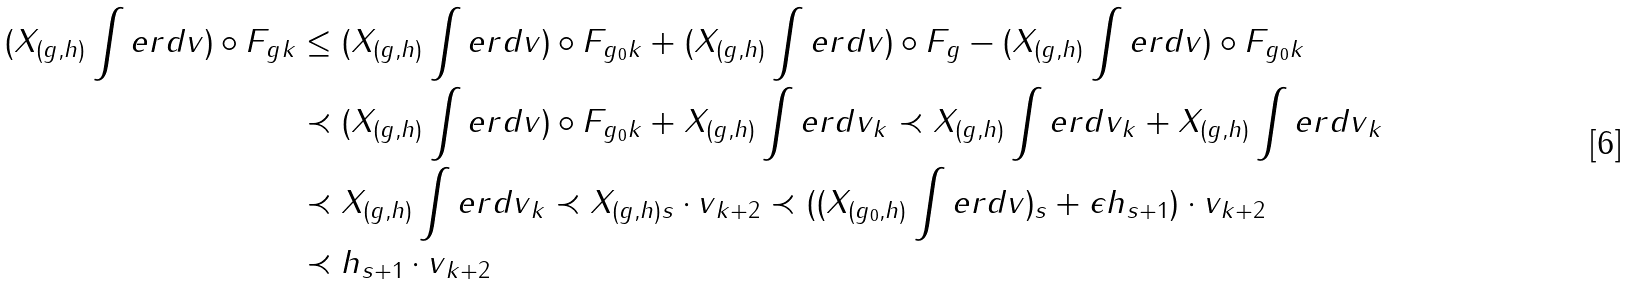<formula> <loc_0><loc_0><loc_500><loc_500>\| ( X _ { ( g , h ) } \int e r d v ) \circ F _ { g } \| _ { k } & \leq \| ( X _ { ( g , h ) } \int e r d v ) \circ F _ { g _ { 0 } } \| _ { k } + \| ( X _ { ( g , h ) } \int e r d v ) \circ F _ { g } - ( X _ { ( g , h ) } \int e r d v ) \circ F _ { g _ { 0 } } \| _ { k } \\ & \prec \| ( X _ { ( g , h ) } \int e r d v ) \circ F _ { g _ { 0 } } \| _ { k } + \| X _ { ( g , h ) } \int e r d v \| _ { k } \prec \| X _ { ( g , h ) } \int e r d v \| _ { k } + \| X _ { ( g , h ) } \int e r d v \| _ { k } \\ & \prec \| X _ { ( g , h ) } \int e r d v \| _ { k } \prec \| X _ { ( g , h ) } \| _ { s } \cdot \| v \| _ { k + 2 } \prec ( \| ( X _ { ( g _ { 0 } , h ) } \int e r d v ) \| _ { s } + \epsilon \| h \| _ { s + 1 } ) \cdot \| v \| _ { k + 2 } \\ & \prec \| h \| _ { s + 1 } \cdot \| v \| _ { k + 2 }</formula> 